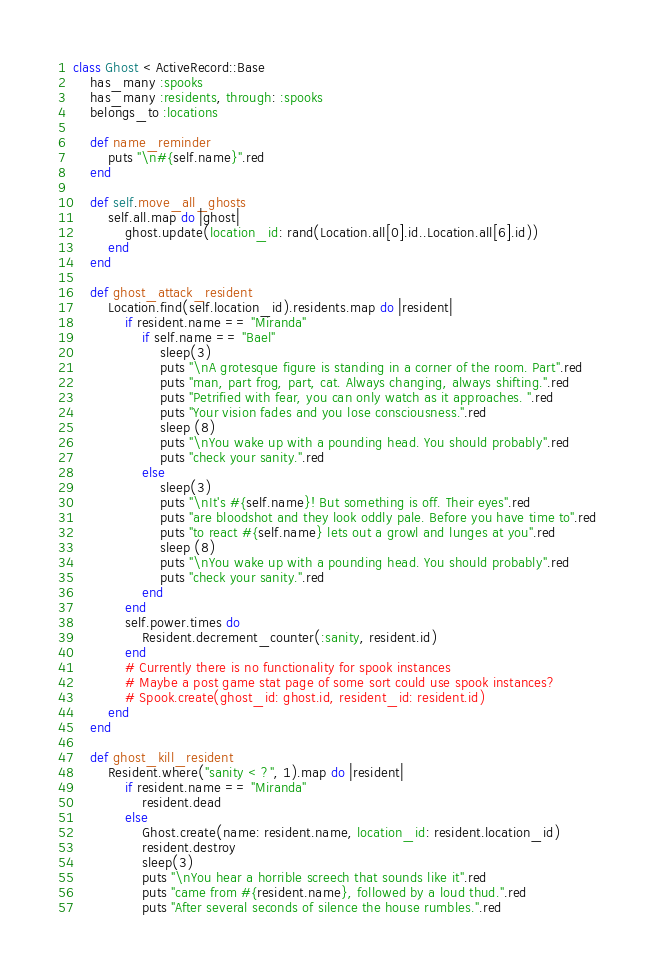<code> <loc_0><loc_0><loc_500><loc_500><_Ruby_>class Ghost < ActiveRecord::Base
    has_many :spooks
    has_many :residents, through: :spooks
    belongs_to :locations

    def name_reminder
        puts "\n#{self.name}".red
    end

    def self.move_all_ghosts
        self.all.map do |ghost|
            ghost.update(location_id: rand(Location.all[0].id..Location.all[6].id))
        end
    end

    def ghost_attack_resident
        Location.find(self.location_id).residents.map do |resident|
            if resident.name == "Miranda"
                if self.name == "Bael"
                    sleep(3)
                    puts "\nA grotesque figure is standing in a corner of the room. Part".red
                    puts "man, part frog, part, cat. Always changing, always shifting.".red
                    puts "Petrified with fear, you can only watch as it approaches. ".red
                    puts "Your vision fades and you lose consciousness.".red
                    sleep (8)
                    puts "\nYou wake up with a pounding head. You should probably".red
                    puts "check your sanity.".red
                else
                    sleep(3)
                    puts "\nIt's #{self.name}! But something is off. Their eyes".red
                    puts "are bloodshot and they look oddly pale. Before you have time to".red
                    puts "to react #{self.name} lets out a growl and lunges at you".red
                    sleep (8)
                    puts "\nYou wake up with a pounding head. You should probably".red
                    puts "check your sanity.".red
                end
            end
            self.power.times do
                Resident.decrement_counter(:sanity, resident.id)
            end
            # Currently there is no functionality for spook instances
            # Maybe a post game stat page of some sort could use spook instances?
            # Spook.create(ghost_id: ghost.id, resident_id: resident.id)
        end
    end

    def ghost_kill_resident
        Resident.where("sanity < ?", 1).map do |resident|
            if resident.name == "Miranda"
                resident.dead
            else
                Ghost.create(name: resident.name, location_id: resident.location_id)
                resident.destroy
                sleep(3)
                puts "\nYou hear a horrible screech that sounds like it".red
                puts "came from #{resident.name}, followed by a loud thud.".red
                puts "After several seconds of silence the house rumbles.".red</code> 